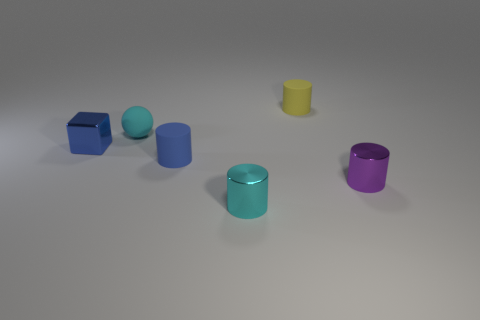Is the color of the metal cylinder that is left of the tiny yellow rubber cylinder the same as the rubber thing that is on the left side of the tiny blue rubber object?
Your answer should be very brief. Yes. What number of purple metal things are right of the small blue metal object?
Offer a very short reply. 1. The block has what size?
Provide a short and direct response. Small. Are the cyan thing that is behind the cyan metallic thing and the object that is behind the cyan matte thing made of the same material?
Offer a terse response. Yes. Is there a tiny matte object that has the same color as the tiny shiny cube?
Offer a very short reply. Yes. There is a rubber ball that is the same size as the shiny cube; what color is it?
Your answer should be very brief. Cyan. There is a cylinder that is on the left side of the cyan metal thing; is it the same color as the cube?
Keep it short and to the point. Yes. Is there a tiny purple cylinder that has the same material as the blue cube?
Make the answer very short. Yes. Is the number of metallic objects that are behind the small blue shiny cube less than the number of yellow things?
Your answer should be very brief. Yes. What number of other tiny things have the same shape as the tiny yellow thing?
Make the answer very short. 3. 